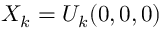Convert formula to latex. <formula><loc_0><loc_0><loc_500><loc_500>X _ { k } = U _ { k } ( 0 , 0 , 0 )</formula> 